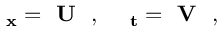Convert formula to latex. <formula><loc_0><loc_0><loc_500><loc_500>\begin{array} { r } { \Psi _ { x } = U \Psi , \Psi _ { t } = V \Psi , } \end{array}</formula> 